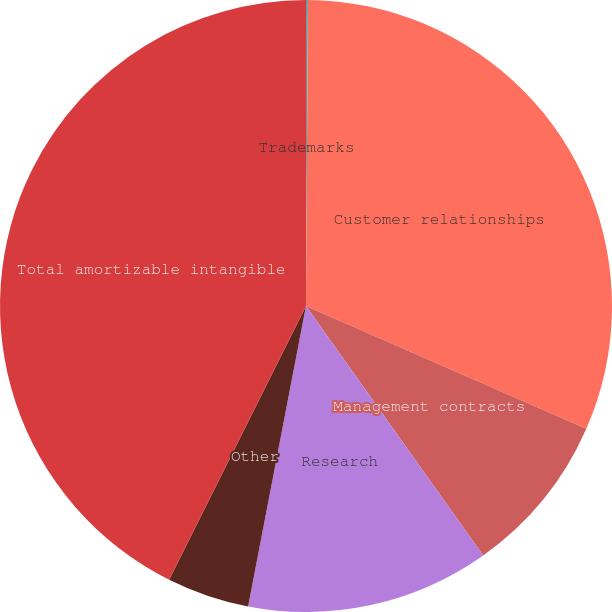Convert chart to OTSL. <chart><loc_0><loc_0><loc_500><loc_500><pie_chart><fcel>Trademarks<fcel>Customer relationships<fcel>Management contracts<fcel>Research<fcel>Other<fcel>Total amortizable intangible<nl><fcel>0.1%<fcel>31.47%<fcel>8.6%<fcel>12.86%<fcel>4.35%<fcel>42.62%<nl></chart> 